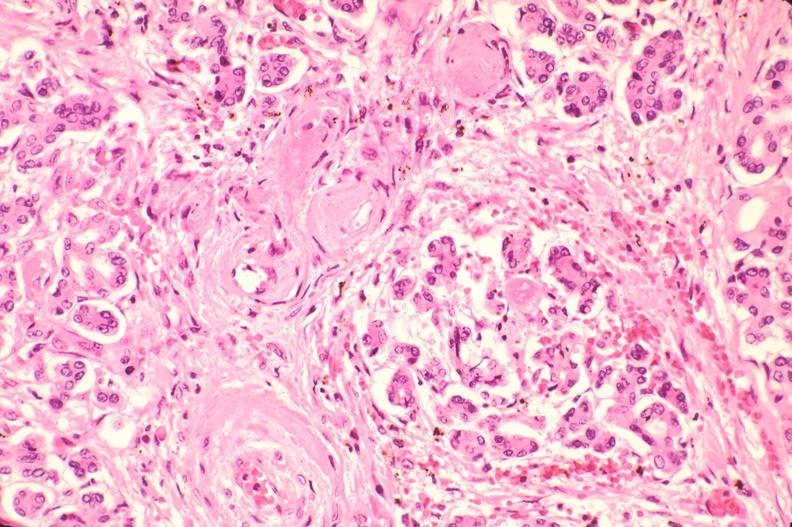does hematoma show pancreas, microthrombi, thrombotic thrombocytopenic purpura?
Answer the question using a single word or phrase. No 